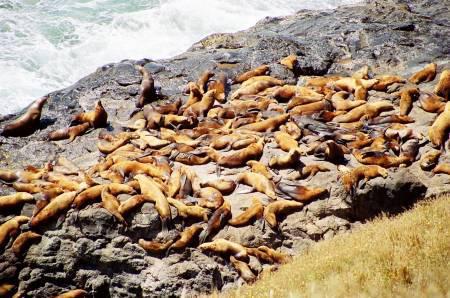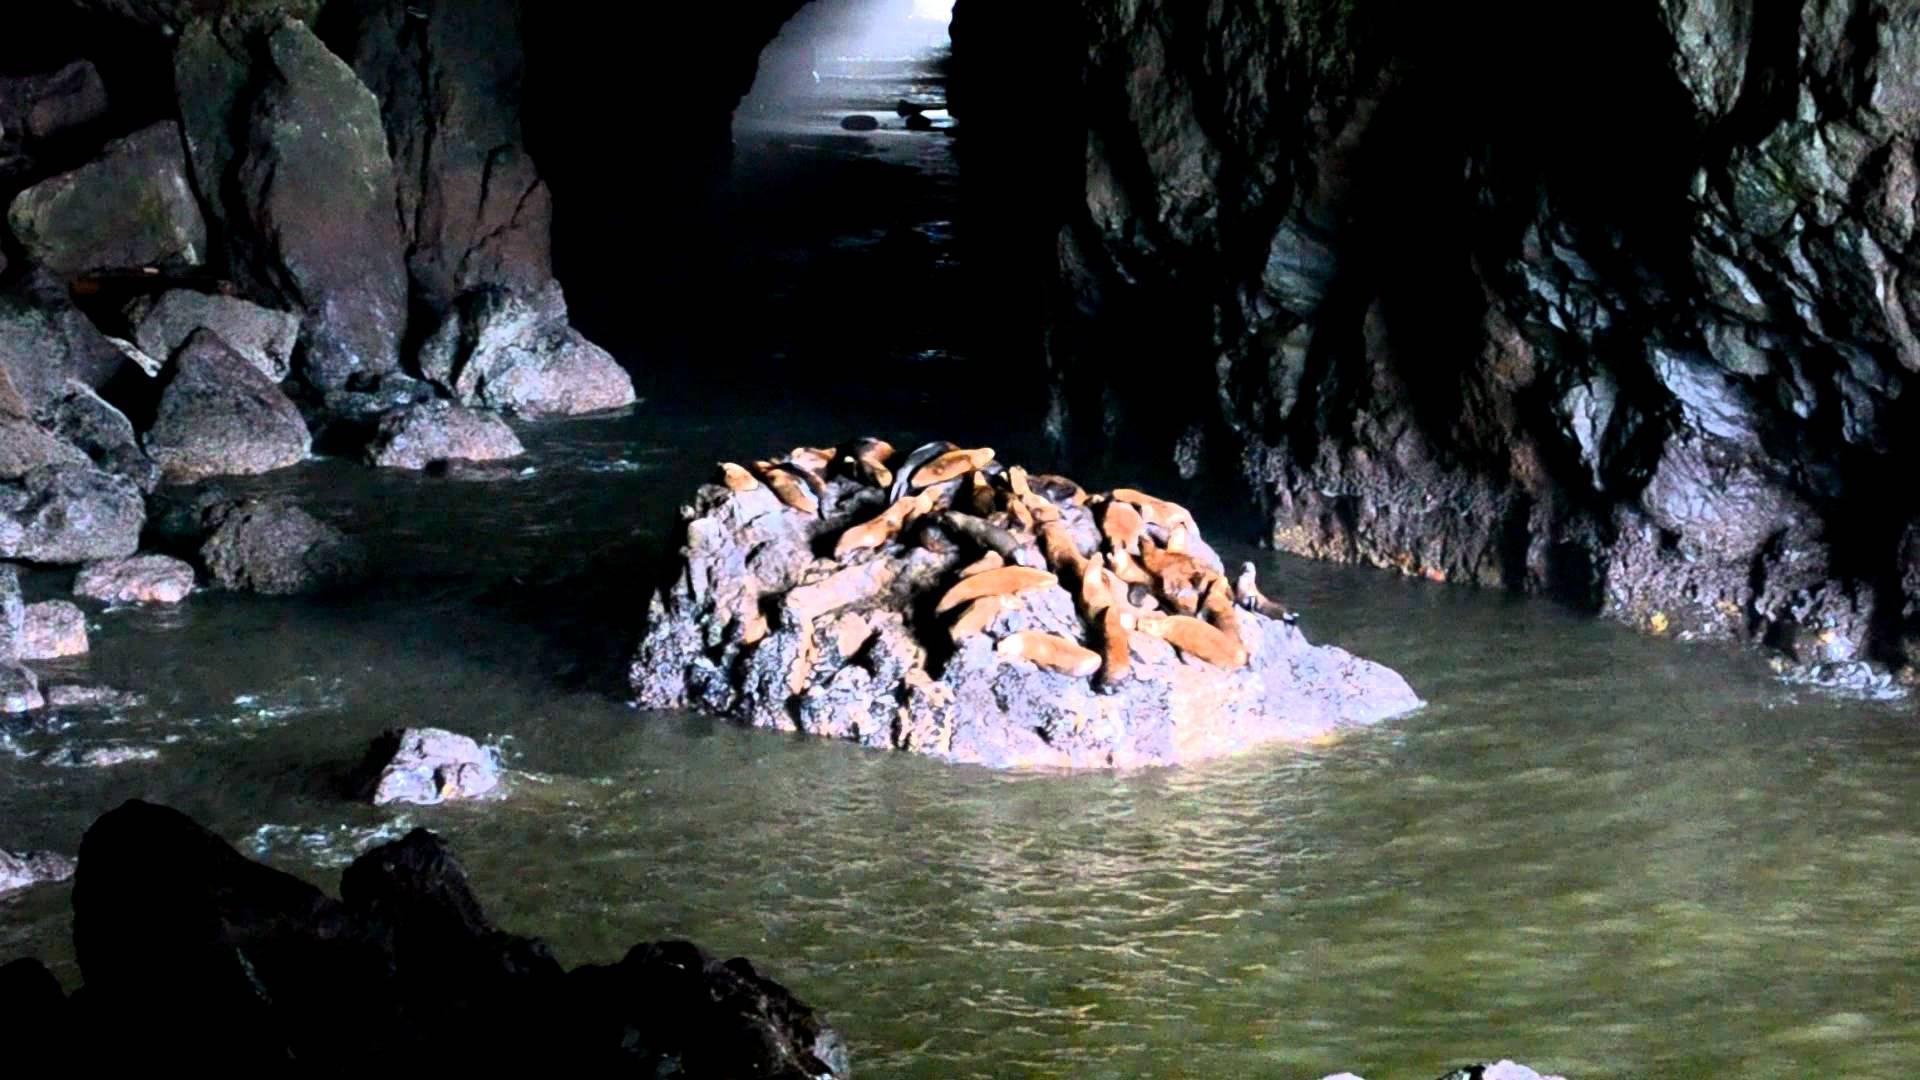The first image is the image on the left, the second image is the image on the right. For the images displayed, is the sentence "One or more of the photos shows sealions on a rock inside a cave." factually correct? Answer yes or no. Yes. The first image is the image on the left, the second image is the image on the right. Examine the images to the left and right. Is the description "At least one image features a small island full of seals." accurate? Answer yes or no. Yes. 